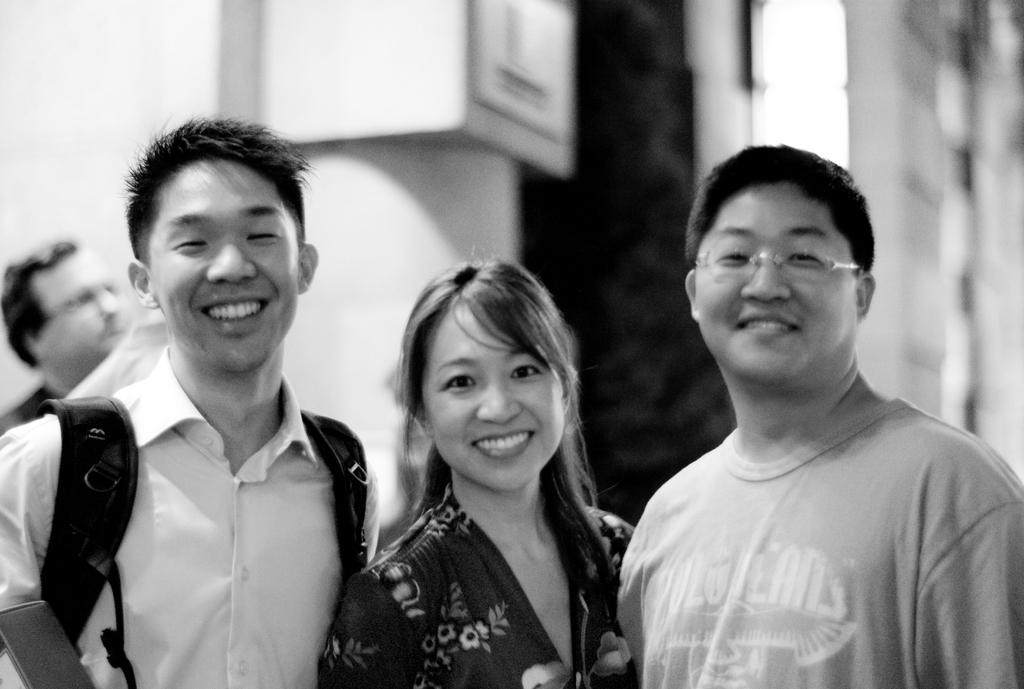How many people are in the foreground of the image? There are two men and a woman in the foreground of the image. What are the people in the foreground doing? They are standing and posing for a camera. What is the color scheme of the image? The image is in black and white. Can you describe the background of the image? There are people visible in the background of the image, but their details are not clear. What type of jeans is the woman wearing in the image? There is no information about the type of jeans the woman is wearing in the image, as it is in black and white and the focus is on the people posing for the camera. 